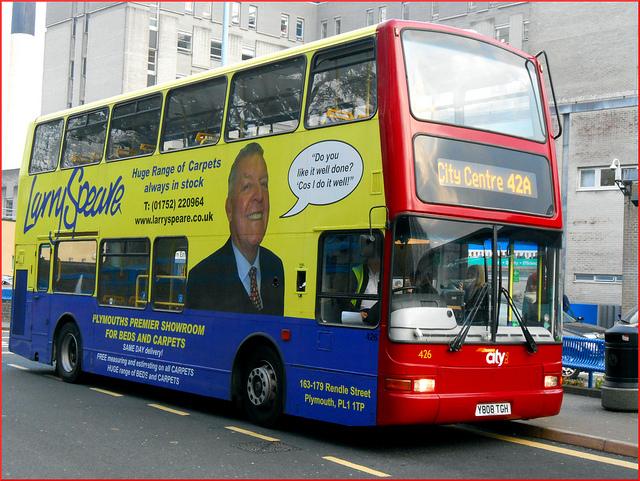What 3 colors is on this bus?
Write a very short answer. Yellow blue red. What is the man on the bus saying?
Write a very short answer. Do you like it well done? cos i do it well. Which bus line is this?
Answer briefly. City. Does this bus cater to handicapped people?
Concise answer only. Yes. 